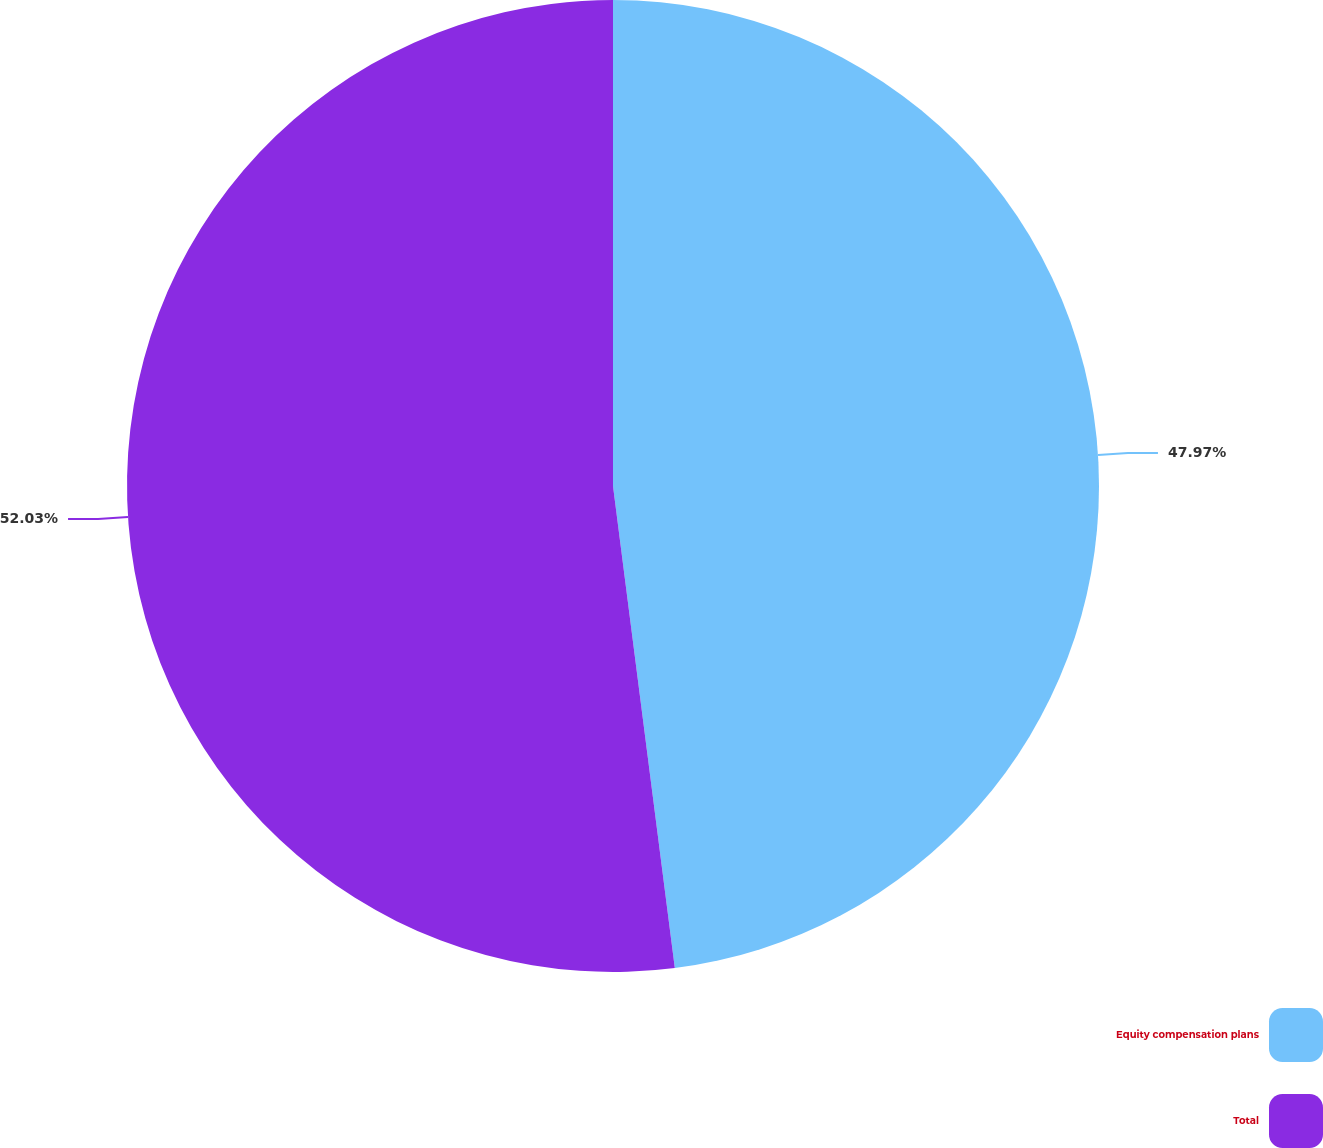Convert chart to OTSL. <chart><loc_0><loc_0><loc_500><loc_500><pie_chart><fcel>Equity compensation plans<fcel>Total<nl><fcel>47.97%<fcel>52.03%<nl></chart> 